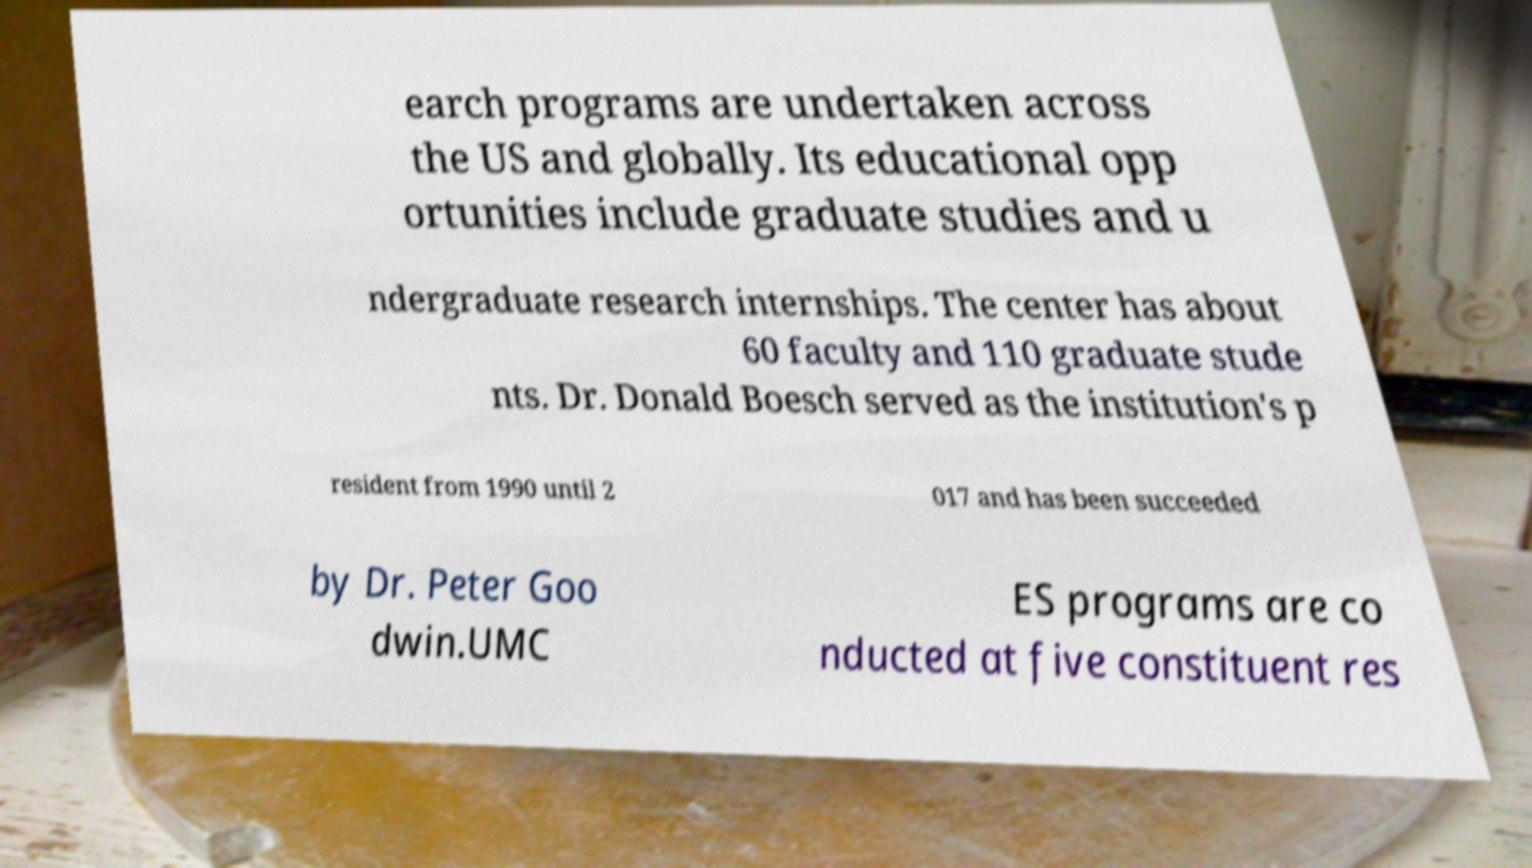There's text embedded in this image that I need extracted. Can you transcribe it verbatim? earch programs are undertaken across the US and globally. Its educational opp ortunities include graduate studies and u ndergraduate research internships. The center has about 60 faculty and 110 graduate stude nts. Dr. Donald Boesch served as the institution's p resident from 1990 until 2 017 and has been succeeded by Dr. Peter Goo dwin.UMC ES programs are co nducted at five constituent res 